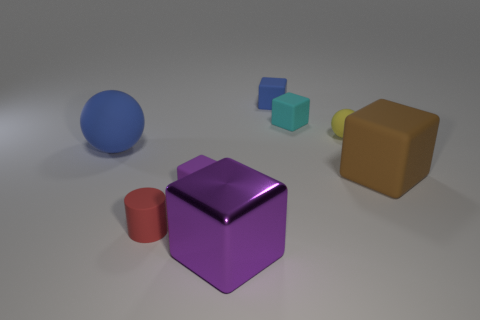Subtract all blue rubber cubes. How many cubes are left? 4 Add 1 small cyan things. How many objects exist? 9 Subtract all purple blocks. How many blocks are left? 3 Subtract all cubes. How many objects are left? 3 Subtract 1 cylinders. How many cylinders are left? 0 Subtract 1 yellow spheres. How many objects are left? 7 Subtract all gray cylinders. Subtract all yellow blocks. How many cylinders are left? 1 Subtract all brown cylinders. How many brown cubes are left? 1 Subtract all matte spheres. Subtract all tiny blue cylinders. How many objects are left? 6 Add 2 big rubber balls. How many big rubber balls are left? 3 